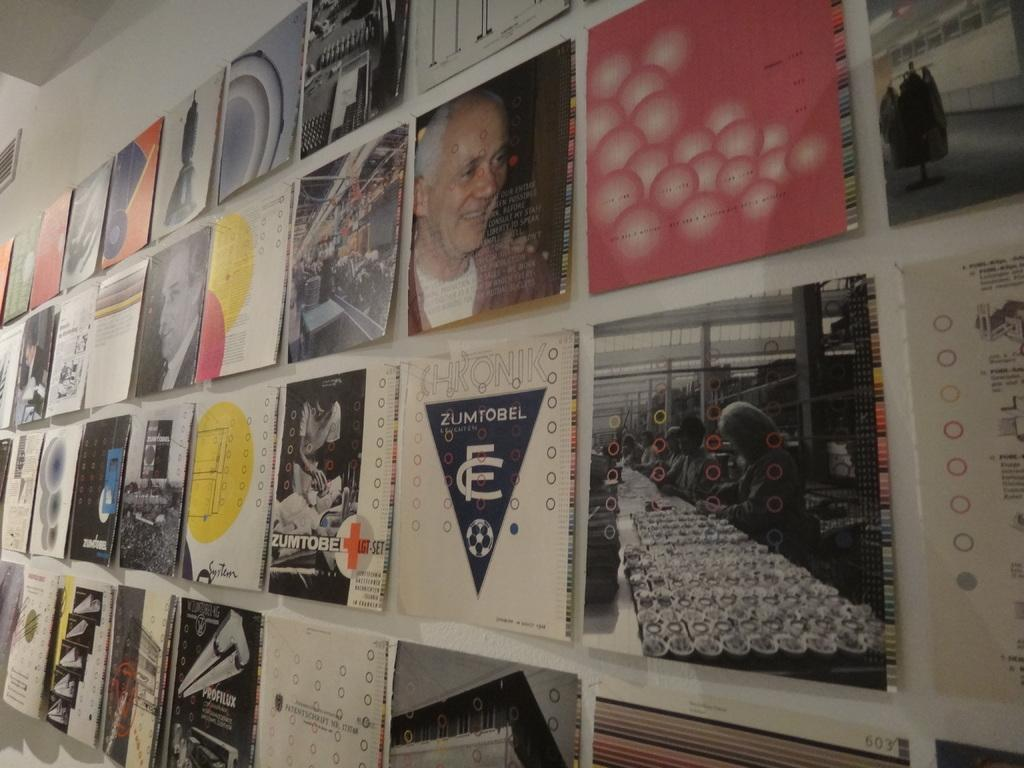<image>
Offer a succinct explanation of the picture presented. Album covers on a wall with one that says Zumtobel. 